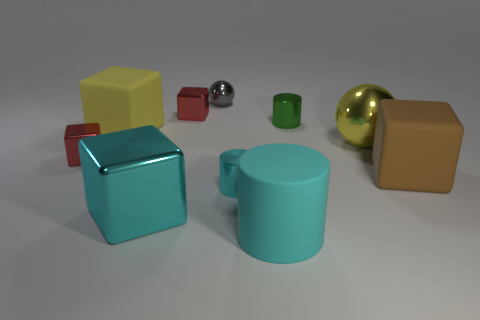Subtract all red spheres. How many cyan cylinders are left? 2 Subtract 1 blocks. How many blocks are left? 4 Subtract all yellow blocks. How many blocks are left? 4 Subtract all cyan cubes. How many cubes are left? 4 Subtract all blue cylinders. Subtract all brown blocks. How many cylinders are left? 3 Subtract all large yellow balls. Subtract all gray rubber spheres. How many objects are left? 9 Add 7 large cyan blocks. How many large cyan blocks are left? 8 Add 6 red blocks. How many red blocks exist? 8 Subtract 0 yellow cylinders. How many objects are left? 10 Subtract all cylinders. How many objects are left? 7 